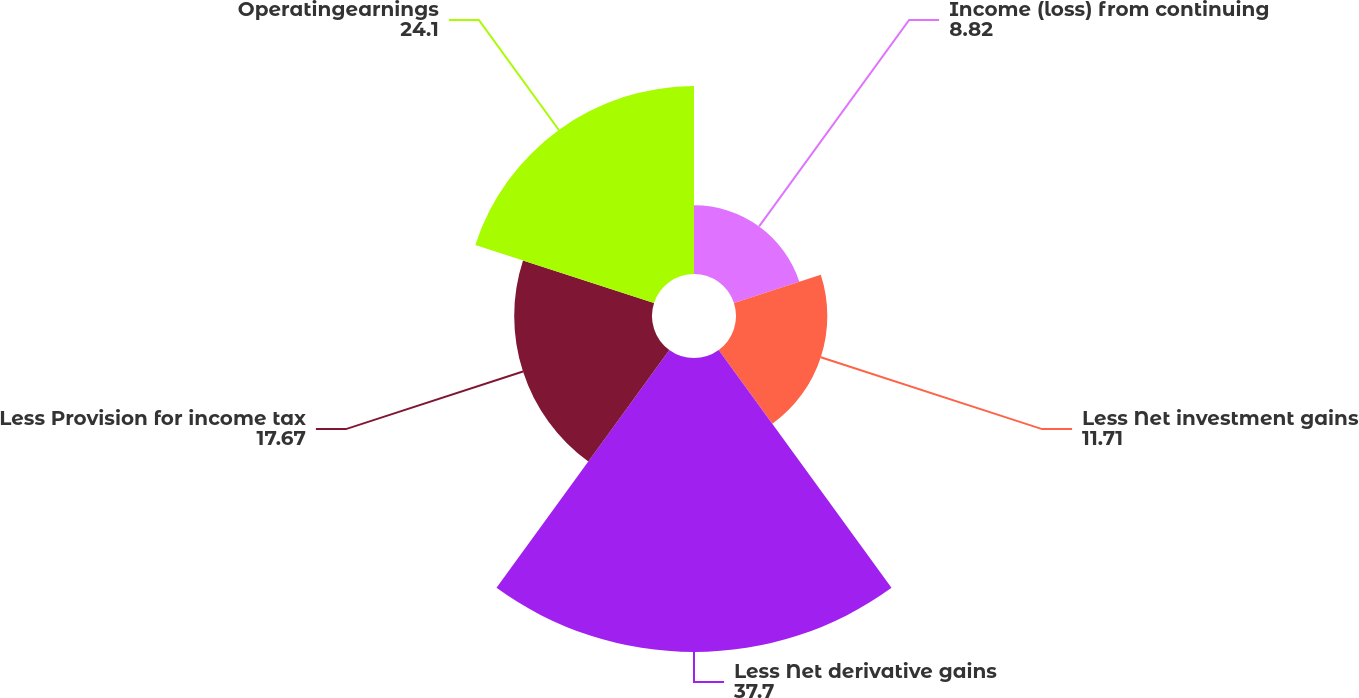<chart> <loc_0><loc_0><loc_500><loc_500><pie_chart><fcel>Income (loss) from continuing<fcel>Less Net investment gains<fcel>Less Net derivative gains<fcel>Less Provision for income tax<fcel>Operatingearnings<nl><fcel>8.82%<fcel>11.71%<fcel>37.7%<fcel>17.67%<fcel>24.1%<nl></chart> 